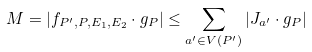<formula> <loc_0><loc_0><loc_500><loc_500>M = | f _ { P ^ { \prime } , P , E _ { 1 } , E _ { 2 } } \cdot g _ { P } | \leq \sum _ { a ^ { \prime } \in V ( P ^ { \prime } ) } { | J _ { a ^ { \prime } } \cdot g _ { P } | }</formula> 